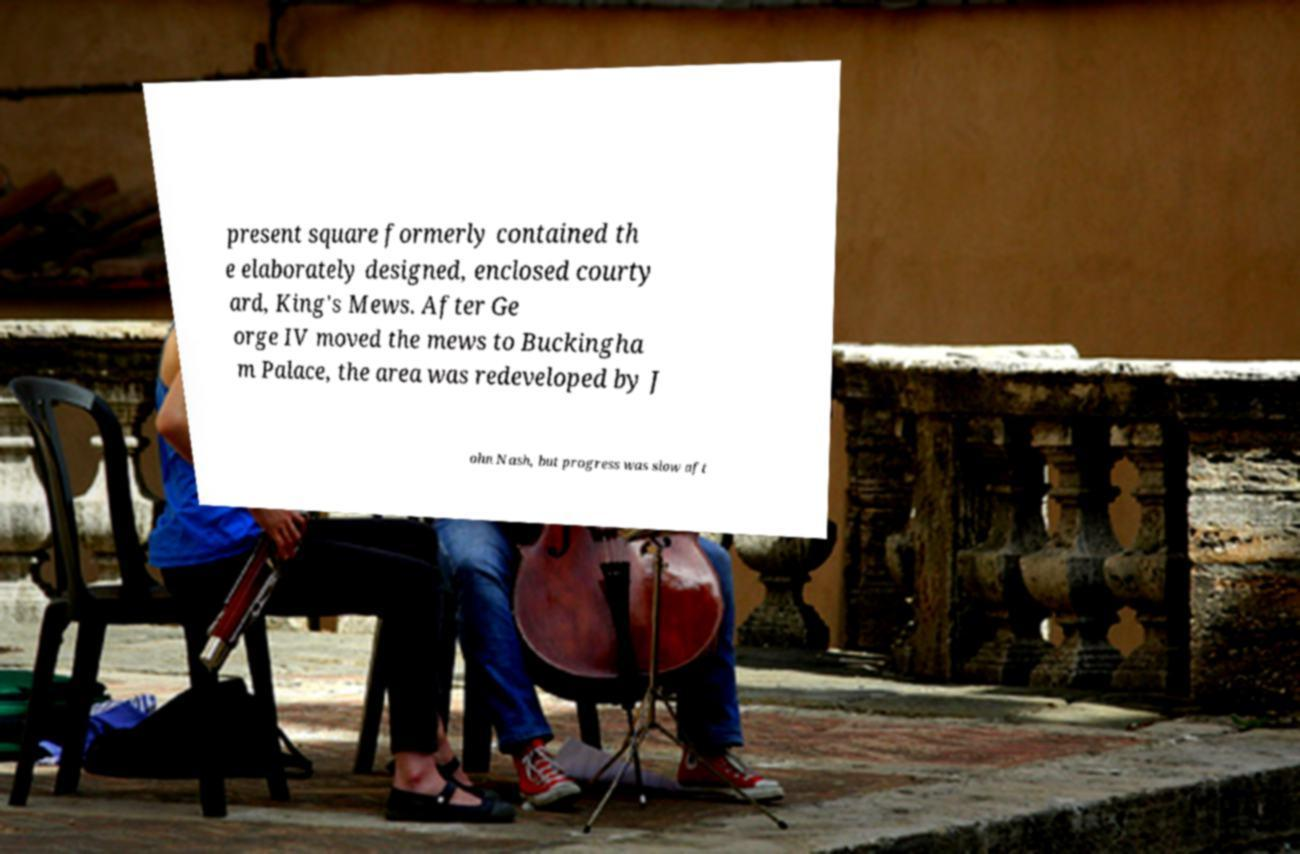Could you extract and type out the text from this image? present square formerly contained th e elaborately designed, enclosed courty ard, King's Mews. After Ge orge IV moved the mews to Buckingha m Palace, the area was redeveloped by J ohn Nash, but progress was slow aft 